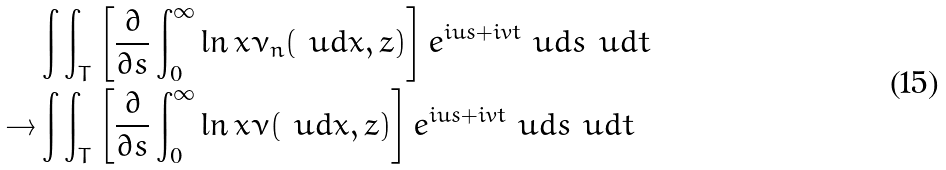<formula> <loc_0><loc_0><loc_500><loc_500>& \int \int _ { T } \left [ \frac { \partial } { \partial s } \int _ { 0 } ^ { \infty } \ln x \nu _ { n } ( \ u d x , z ) \right ] e ^ { i u s + i v t } \ u d s \ u d t \\ \rightarrow & \int \int _ { T } \left [ \frac { \partial } { \partial s } \int _ { 0 } ^ { \infty } \ln x \nu ( \ u d x , z ) \right ] e ^ { i u s + i v t } \ u d s \ u d t \\</formula> 